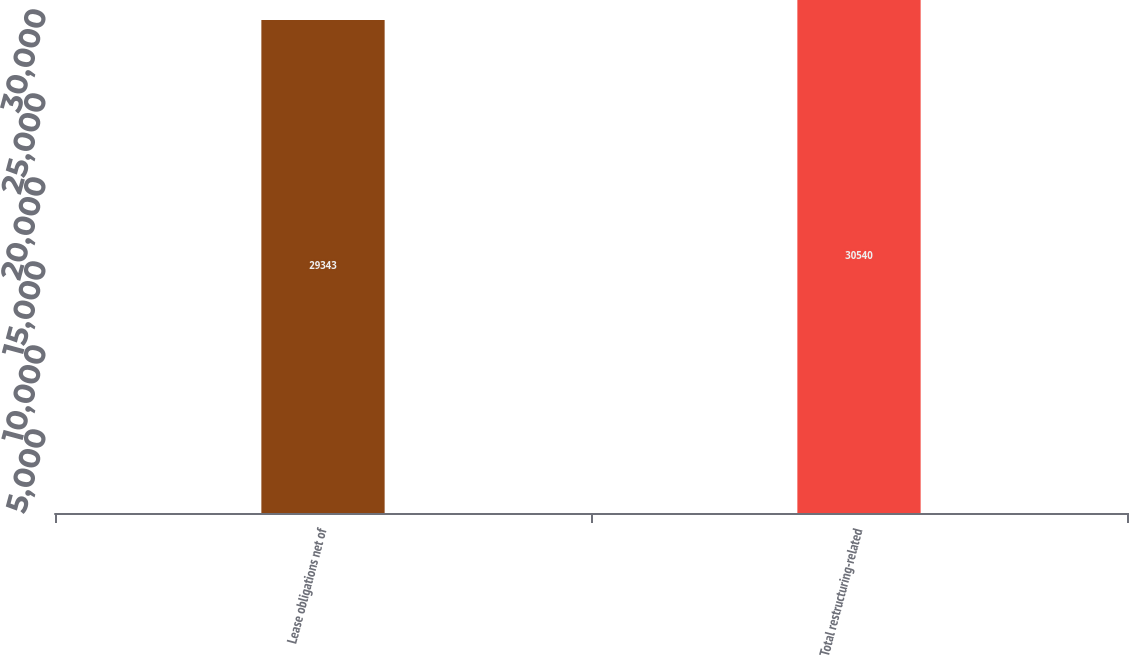Convert chart to OTSL. <chart><loc_0><loc_0><loc_500><loc_500><bar_chart><fcel>Lease obligations net of<fcel>Total restructuring-related<nl><fcel>29343<fcel>30540<nl></chart> 